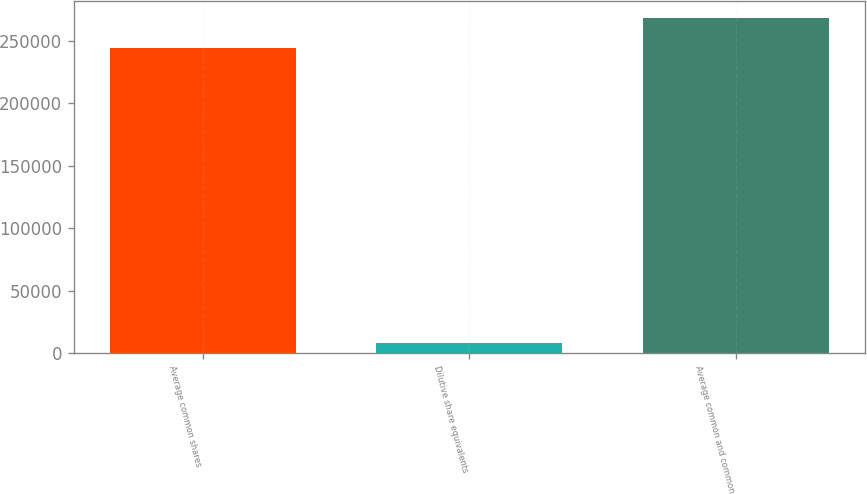<chart> <loc_0><loc_0><loc_500><loc_500><bar_chart><fcel>Average common shares<fcel>Dilutive share equivalents<fcel>Average common and common<nl><fcel>244323<fcel>8358<fcel>268755<nl></chart> 